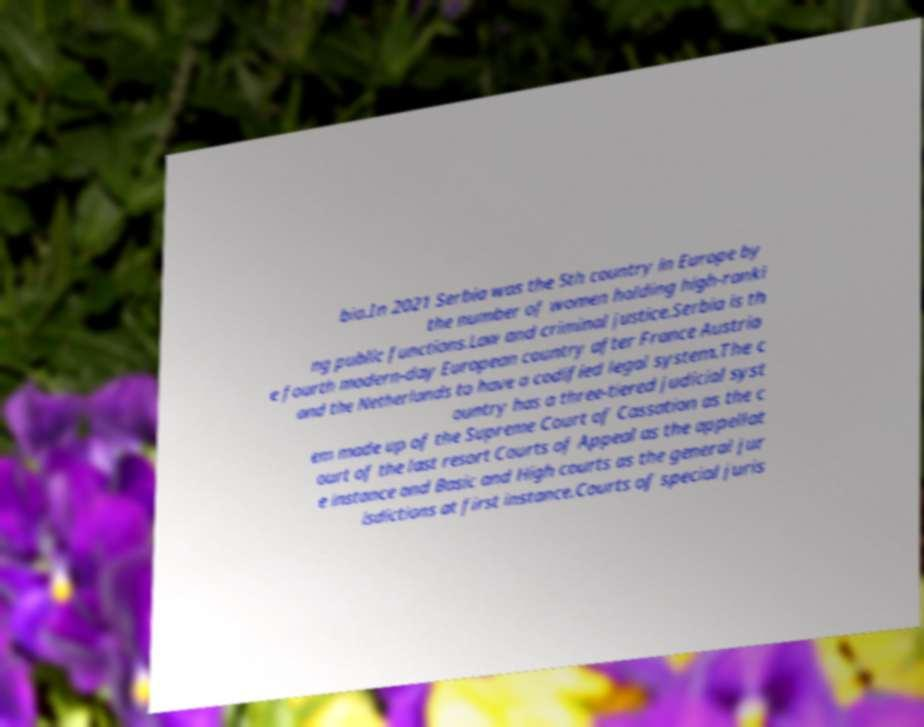Could you extract and type out the text from this image? bia.In 2021 Serbia was the 5th country in Europe by the number of women holding high-ranki ng public functions.Law and criminal justice.Serbia is th e fourth modern-day European country after France Austria and the Netherlands to have a codified legal system.The c ountry has a three-tiered judicial syst em made up of the Supreme Court of Cassation as the c ourt of the last resort Courts of Appeal as the appellat e instance and Basic and High courts as the general jur isdictions at first instance.Courts of special juris 